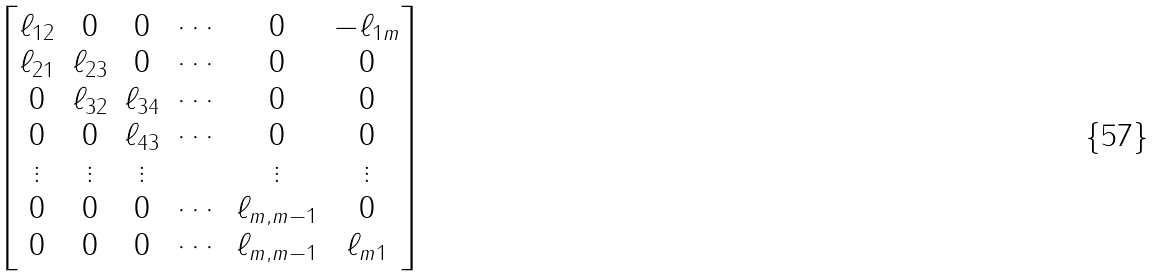Convert formula to latex. <formula><loc_0><loc_0><loc_500><loc_500>\begin{bmatrix} \ell _ { 1 2 } & 0 & 0 & \cdots & 0 & - \ell _ { 1 m } \\ \ell _ { 2 1 } & \ell _ { 2 3 } & 0 & \cdots & 0 & 0 \\ 0 & \ell _ { 3 2 } & \ell _ { 3 4 } & \cdots & 0 & 0 \\ 0 & 0 & \ell _ { 4 3 } & \cdots & 0 & 0 \\ \vdots & \vdots & \vdots & & \vdots & \vdots \\ 0 & 0 & 0 & \cdots & \ell _ { m , m - 1 } & 0 \\ 0 & 0 & 0 & \cdots & \ell _ { m , m - 1 } & \ell _ { m 1 } \end{bmatrix}</formula> 